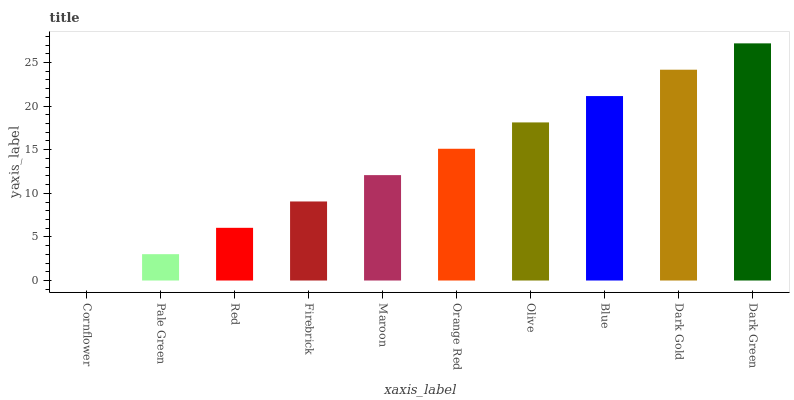Is Pale Green the minimum?
Answer yes or no. No. Is Pale Green the maximum?
Answer yes or no. No. Is Pale Green greater than Cornflower?
Answer yes or no. Yes. Is Cornflower less than Pale Green?
Answer yes or no. Yes. Is Cornflower greater than Pale Green?
Answer yes or no. No. Is Pale Green less than Cornflower?
Answer yes or no. No. Is Orange Red the high median?
Answer yes or no. Yes. Is Maroon the low median?
Answer yes or no. Yes. Is Pale Green the high median?
Answer yes or no. No. Is Dark Green the low median?
Answer yes or no. No. 